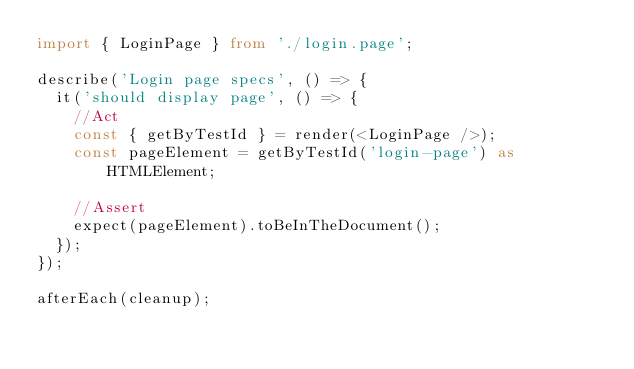<code> <loc_0><loc_0><loc_500><loc_500><_TypeScript_>import { LoginPage } from './login.page';

describe('Login page specs', () => {
  it('should display page', () => {
    //Act
    const { getByTestId } = render(<LoginPage />);
    const pageElement = getByTestId('login-page') as HTMLElement;
    
    //Assert
    expect(pageElement).toBeInTheDocument();
  });
});

afterEach(cleanup);</code> 